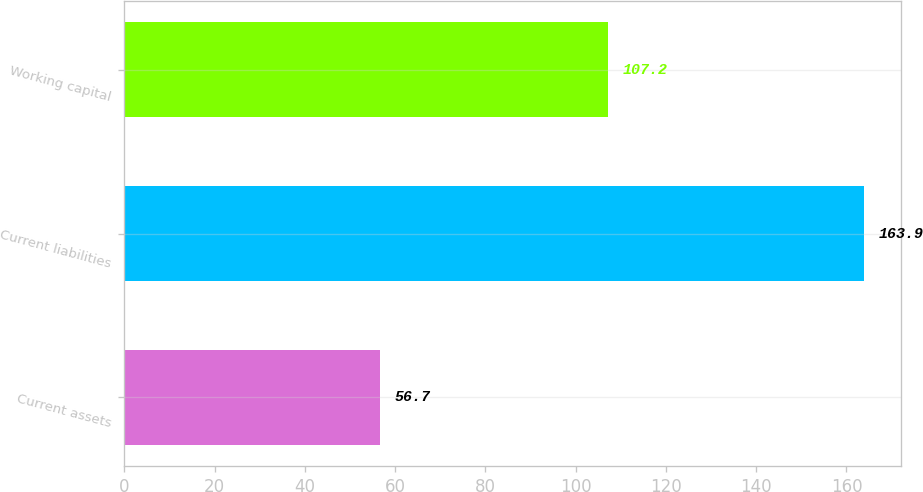Convert chart. <chart><loc_0><loc_0><loc_500><loc_500><bar_chart><fcel>Current assets<fcel>Current liabilities<fcel>Working capital<nl><fcel>56.7<fcel>163.9<fcel>107.2<nl></chart> 